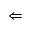Convert formula to latex. <formula><loc_0><loc_0><loc_500><loc_500>\Leftarrow</formula> 